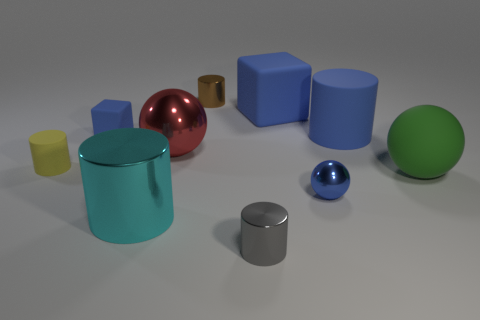Subtract all shiny cylinders. How many cylinders are left? 2 Subtract all green spheres. How many spheres are left? 2 Subtract all spheres. How many objects are left? 7 Subtract 1 balls. How many balls are left? 2 Subtract all red spheres. Subtract all red cylinders. How many spheres are left? 2 Subtract 0 brown blocks. How many objects are left? 10 Subtract all gray blocks. How many purple cylinders are left? 0 Subtract all blue rubber cylinders. Subtract all yellow matte cylinders. How many objects are left? 8 Add 4 small blue cubes. How many small blue cubes are left? 5 Add 2 tiny yellow matte cylinders. How many tiny yellow matte cylinders exist? 3 